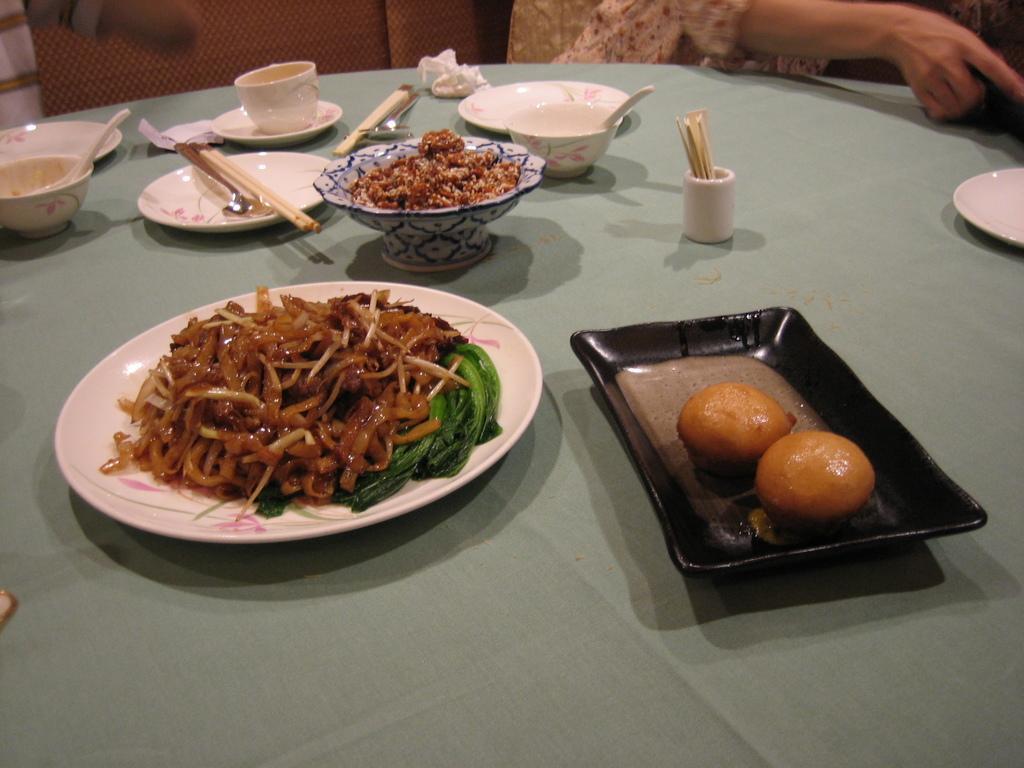How would you summarize this image in a sentence or two? There is a table which is covered by a green color cloth and on that table there is a plate which contains some food items and a glass and some food containers on the table and a woman is sitting and in the background there is a brown color wall. 